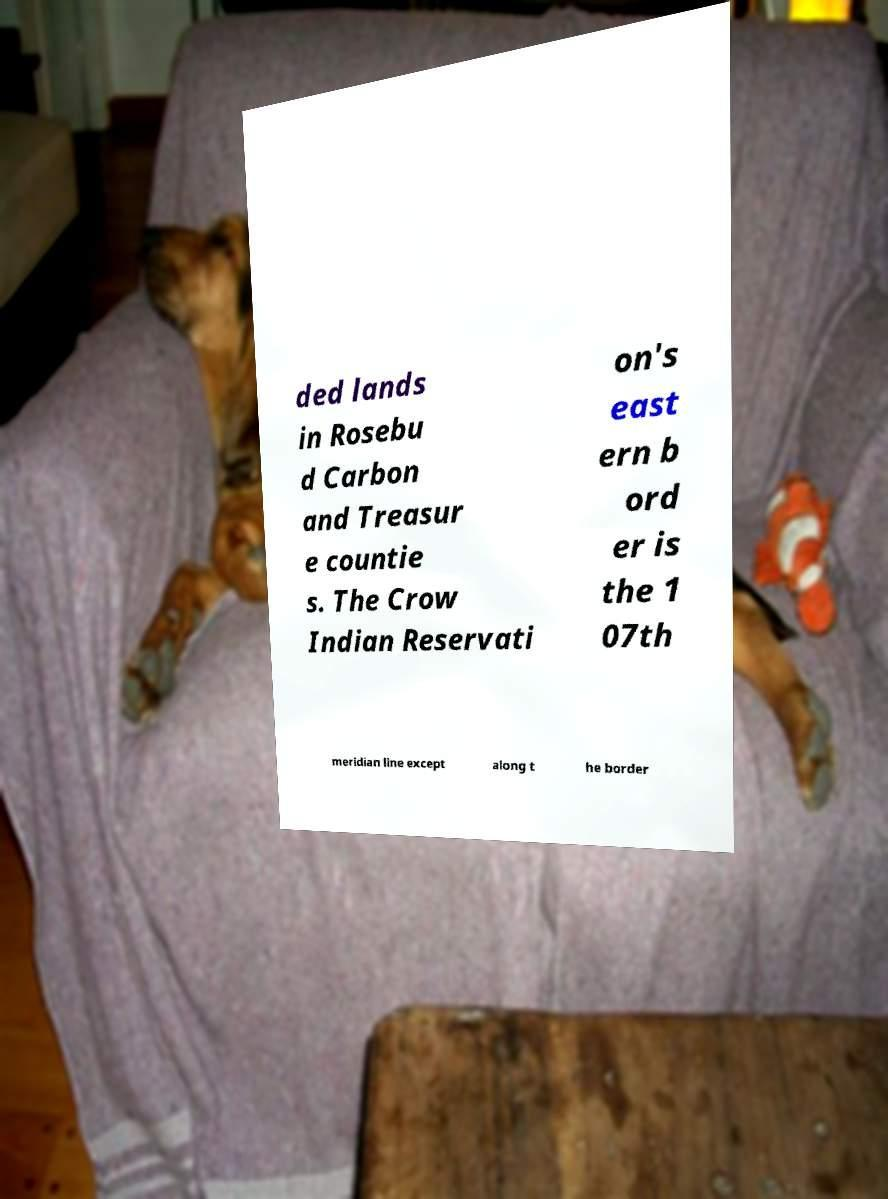Please identify and transcribe the text found in this image. ded lands in Rosebu d Carbon and Treasur e countie s. The Crow Indian Reservati on's east ern b ord er is the 1 07th meridian line except along t he border 